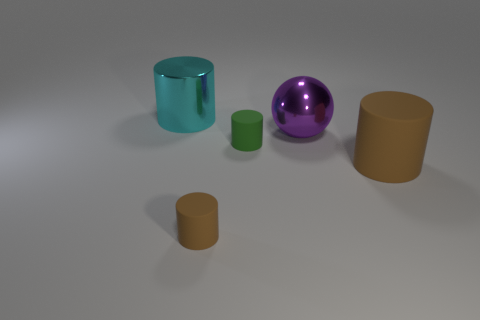Subtract all gray cylinders. Subtract all green cubes. How many cylinders are left? 4 Add 2 small cyan metallic things. How many objects exist? 7 Subtract all cylinders. How many objects are left? 1 Subtract 0 blue cylinders. How many objects are left? 5 Subtract all large shiny balls. Subtract all blue objects. How many objects are left? 4 Add 3 large metallic things. How many large metallic things are left? 5 Add 4 big green matte cylinders. How many big green matte cylinders exist? 4 